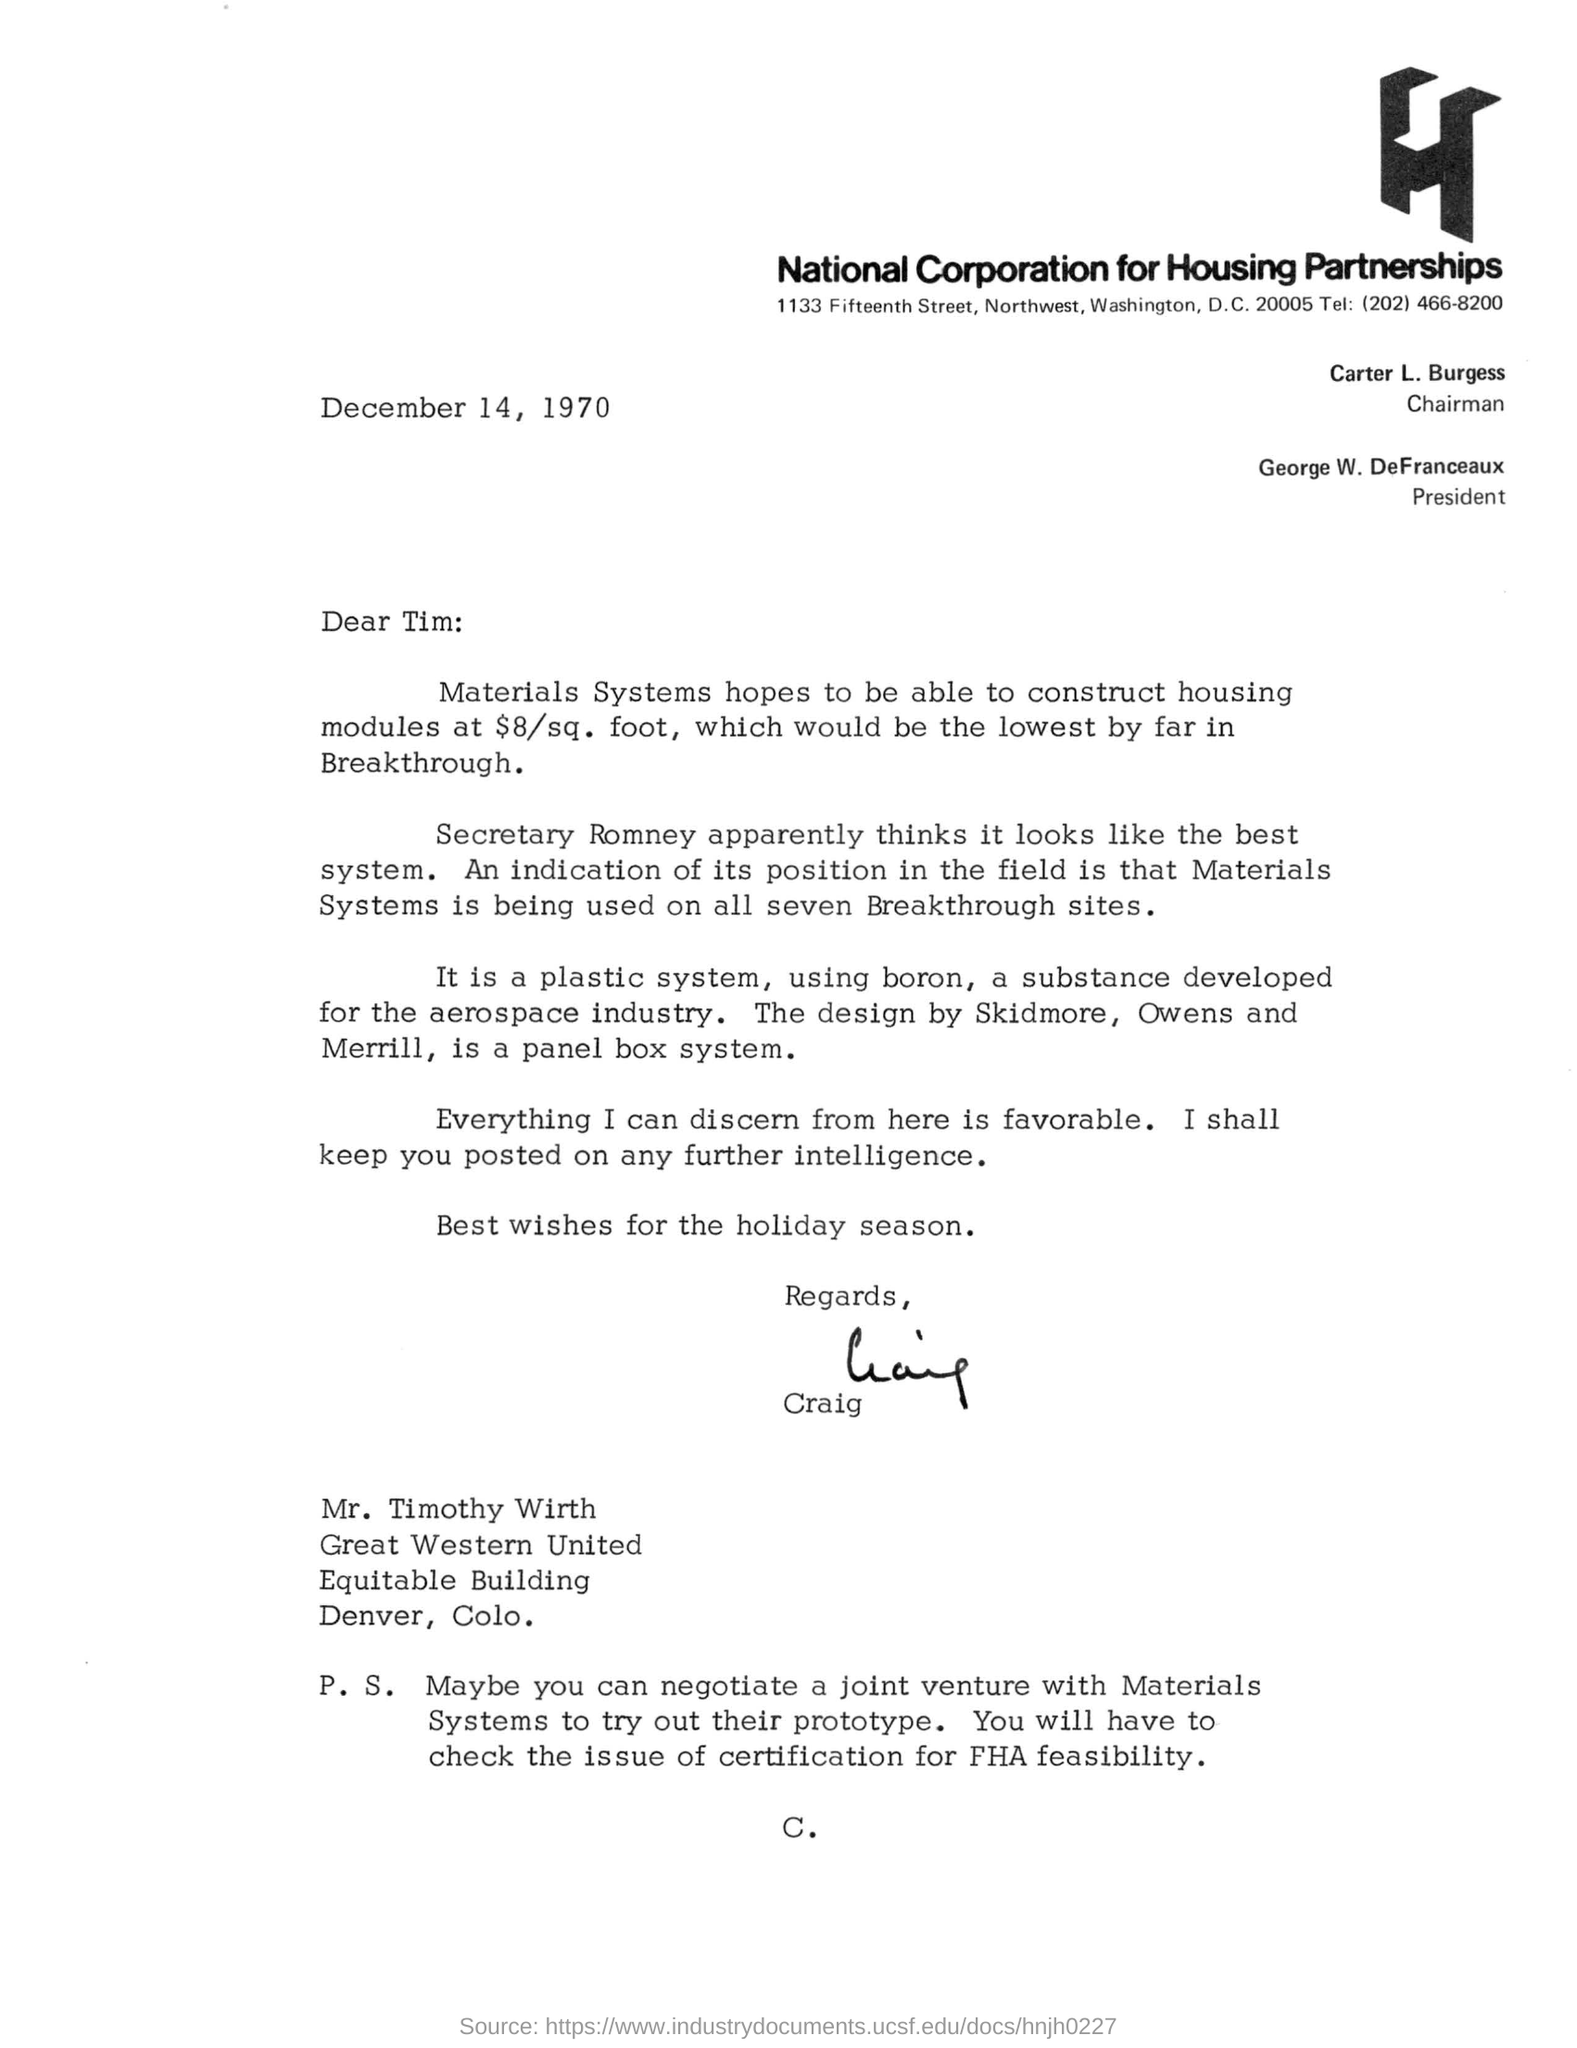Indicate a few pertinent items in this graphic. The person who wrote this letter is Craig. This letter was written on December 14, 1970. The President of the National Corporation for Housing Partnerships is George W. DeFranceaux. The letter was written to the person named Tim. The chairman of the National Corporation for Housing Partnerships is Carter L. Burgess. 